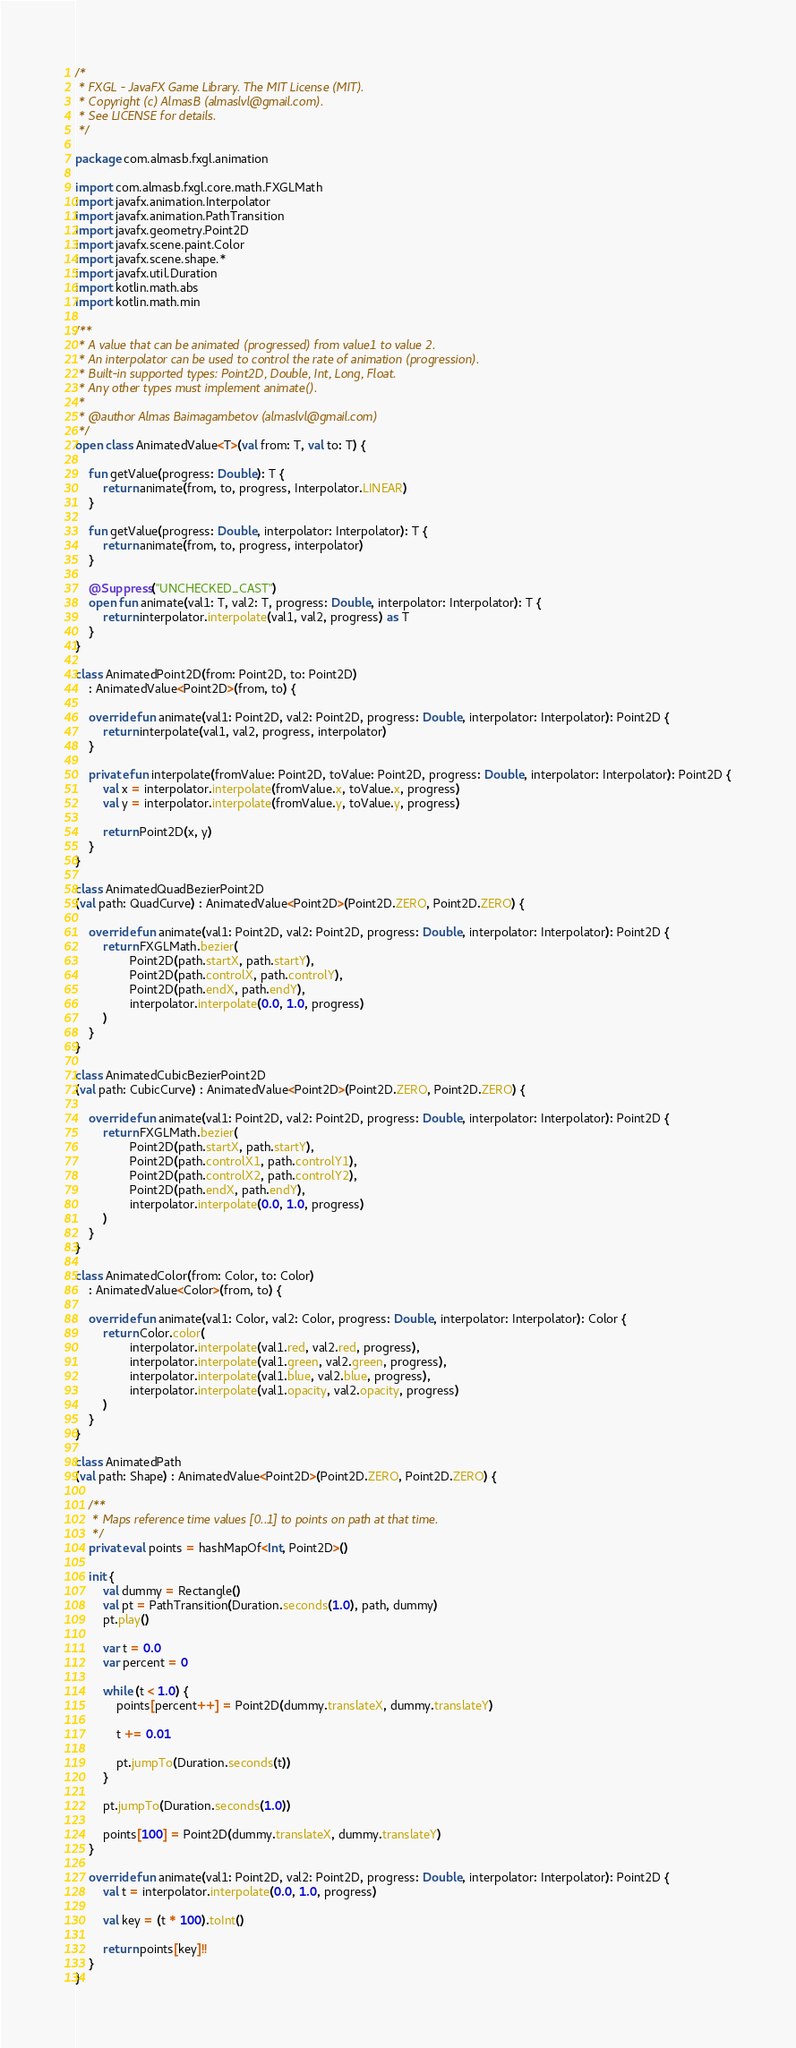Convert code to text. <code><loc_0><loc_0><loc_500><loc_500><_Kotlin_>/*
 * FXGL - JavaFX Game Library. The MIT License (MIT).
 * Copyright (c) AlmasB (almaslvl@gmail.com).
 * See LICENSE for details.
 */

package com.almasb.fxgl.animation

import com.almasb.fxgl.core.math.FXGLMath
import javafx.animation.Interpolator
import javafx.animation.PathTransition
import javafx.geometry.Point2D
import javafx.scene.paint.Color
import javafx.scene.shape.*
import javafx.util.Duration
import kotlin.math.abs
import kotlin.math.min

/**
 * A value that can be animated (progressed) from value1 to value 2.
 * An interpolator can be used to control the rate of animation (progression).
 * Built-in supported types: Point2D, Double, Int, Long, Float.
 * Any other types must implement animate().
 *
 * @author Almas Baimagambetov (almaslvl@gmail.com)
 */
open class AnimatedValue<T>(val from: T, val to: T) {

    fun getValue(progress: Double): T {
        return animate(from, to, progress, Interpolator.LINEAR)
    }

    fun getValue(progress: Double, interpolator: Interpolator): T {
        return animate(from, to, progress, interpolator)
    }

    @Suppress("UNCHECKED_CAST")
    open fun animate(val1: T, val2: T, progress: Double, interpolator: Interpolator): T {
        return interpolator.interpolate(val1, val2, progress) as T
    }
}

class AnimatedPoint2D(from: Point2D, to: Point2D)
    : AnimatedValue<Point2D>(from, to) {

    override fun animate(val1: Point2D, val2: Point2D, progress: Double, interpolator: Interpolator): Point2D {
        return interpolate(val1, val2, progress, interpolator)
    }

    private fun interpolate(fromValue: Point2D, toValue: Point2D, progress: Double, interpolator: Interpolator): Point2D {
        val x = interpolator.interpolate(fromValue.x, toValue.x, progress)
        val y = interpolator.interpolate(fromValue.y, toValue.y, progress)

        return Point2D(x, y)
    }
}

class AnimatedQuadBezierPoint2D
(val path: QuadCurve) : AnimatedValue<Point2D>(Point2D.ZERO, Point2D.ZERO) {

    override fun animate(val1: Point2D, val2: Point2D, progress: Double, interpolator: Interpolator): Point2D {
        return FXGLMath.bezier(
                Point2D(path.startX, path.startY),
                Point2D(path.controlX, path.controlY),
                Point2D(path.endX, path.endY),
                interpolator.interpolate(0.0, 1.0, progress)
        )
    }
}

class AnimatedCubicBezierPoint2D
(val path: CubicCurve) : AnimatedValue<Point2D>(Point2D.ZERO, Point2D.ZERO) {

    override fun animate(val1: Point2D, val2: Point2D, progress: Double, interpolator: Interpolator): Point2D {
        return FXGLMath.bezier(
                Point2D(path.startX, path.startY),
                Point2D(path.controlX1, path.controlY1),
                Point2D(path.controlX2, path.controlY2),
                Point2D(path.endX, path.endY),
                interpolator.interpolate(0.0, 1.0, progress)
        )
    }
}

class AnimatedColor(from: Color, to: Color)
    : AnimatedValue<Color>(from, to) {

    override fun animate(val1: Color, val2: Color, progress: Double, interpolator: Interpolator): Color {
        return Color.color(
                interpolator.interpolate(val1.red, val2.red, progress),
                interpolator.interpolate(val1.green, val2.green, progress),
                interpolator.interpolate(val1.blue, val2.blue, progress),
                interpolator.interpolate(val1.opacity, val2.opacity, progress)
        )
    }
}

class AnimatedPath
(val path: Shape) : AnimatedValue<Point2D>(Point2D.ZERO, Point2D.ZERO) {

    /**
     * Maps reference time values [0..1] to points on path at that time.
     */
    private val points = hashMapOf<Int, Point2D>()

    init {
        val dummy = Rectangle()
        val pt = PathTransition(Duration.seconds(1.0), path, dummy)
        pt.play()

        var t = 0.0
        var percent = 0

        while (t < 1.0) {
            points[percent++] = Point2D(dummy.translateX, dummy.translateY)

            t += 0.01

            pt.jumpTo(Duration.seconds(t))
        }

        pt.jumpTo(Duration.seconds(1.0))

        points[100] = Point2D(dummy.translateX, dummy.translateY)
    }

    override fun animate(val1: Point2D, val2: Point2D, progress: Double, interpolator: Interpolator): Point2D {
        val t = interpolator.interpolate(0.0, 1.0, progress)

        val key = (t * 100).toInt()

        return points[key]!!
    }
}</code> 